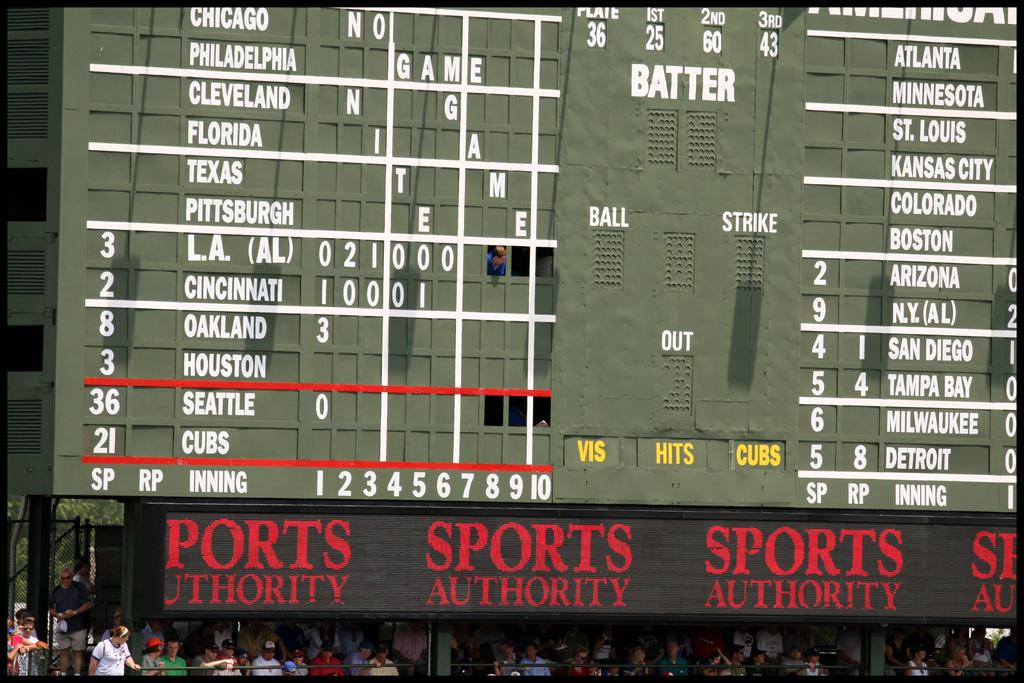<image>
Render a clear and concise summary of the photo. Sports authority game that include baseball teams scores 